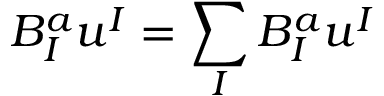Convert formula to latex. <formula><loc_0><loc_0><loc_500><loc_500>B _ { I } ^ { a } u ^ { I } = \sum _ { I } B _ { I } ^ { a } u ^ { I }</formula> 